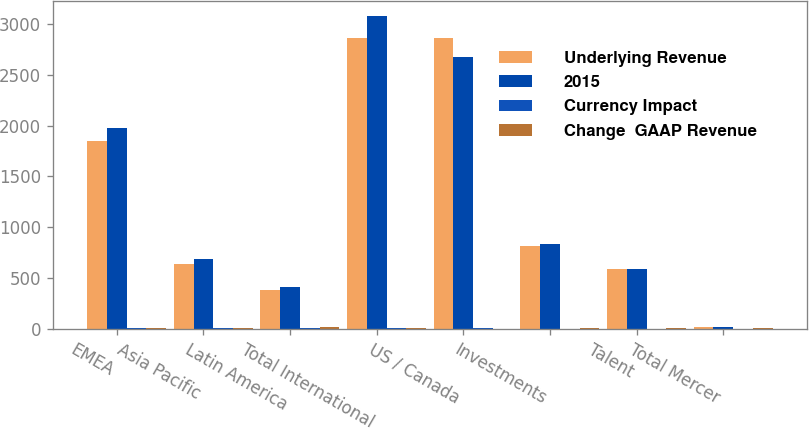<chart> <loc_0><loc_0><loc_500><loc_500><stacked_bar_chart><ecel><fcel>EMEA<fcel>Asia Pacific<fcel>Latin America<fcel>Total International<fcel>US / Canada<fcel>Investments<fcel>Talent<fcel>Total Mercer<nl><fcel>Underlying Revenue<fcel>1848<fcel>636<fcel>380<fcel>2864<fcel>2863<fcel>818<fcel>592<fcel>15<nl><fcel>2015<fcel>1980<fcel>683<fcel>413<fcel>3076<fcel>2677<fcel>836<fcel>586<fcel>15<nl><fcel>Currency Impact<fcel>7<fcel>7<fcel>8<fcel>7<fcel>7<fcel>2<fcel>1<fcel>1<nl><fcel>Change  GAAP Revenue<fcel>10<fcel>10<fcel>18<fcel>11<fcel>1<fcel>12<fcel>7<fcel>7<nl></chart> 